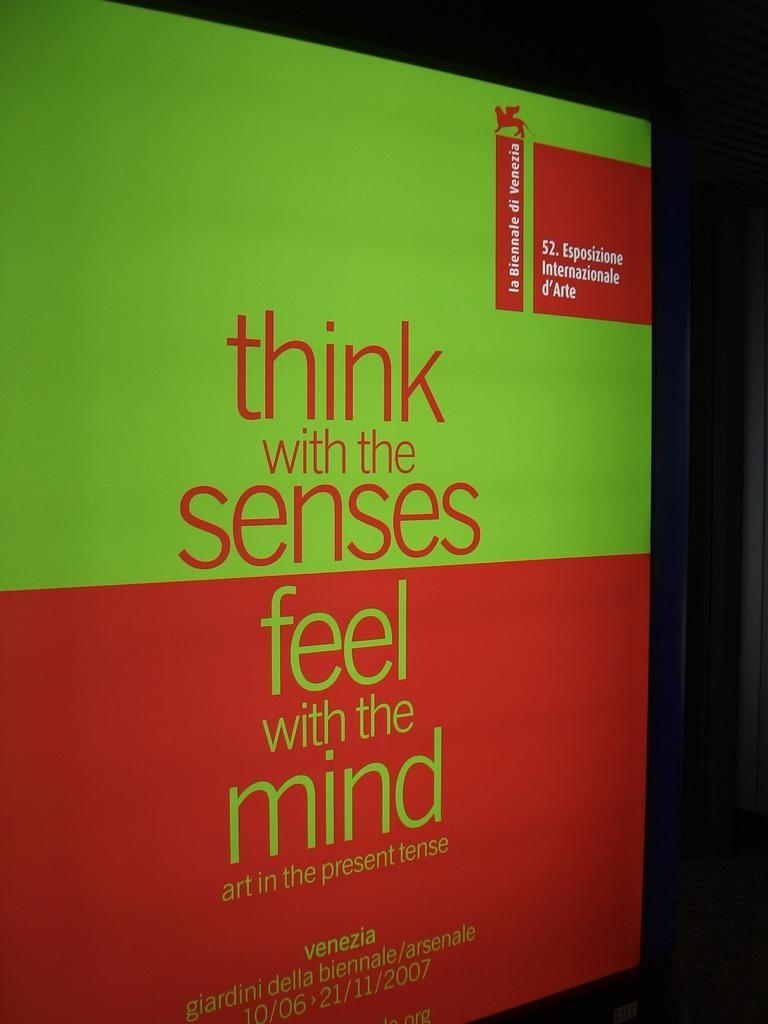<image>
Present a compact description of the photo's key features. Green and red box says think with the senses, feel with the mindl 